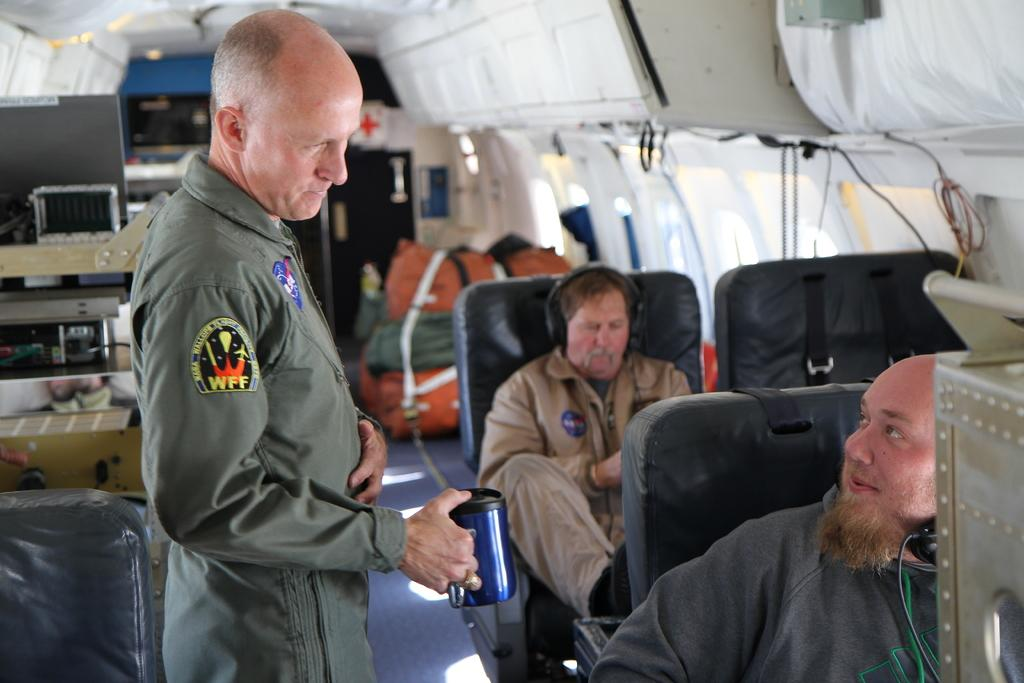What are the men in the image doing? The men in the image are seated on chairs. Is there anyone standing in the image? Yes, there is a man standing in the image. What objects can be seen near the seated men? Bags are visible in the image. Can you describe the man with a unique accessory? There is a man wearing a headset in the image. What type of yoke is being used by the men in the image? There is no yoke present in the image. 